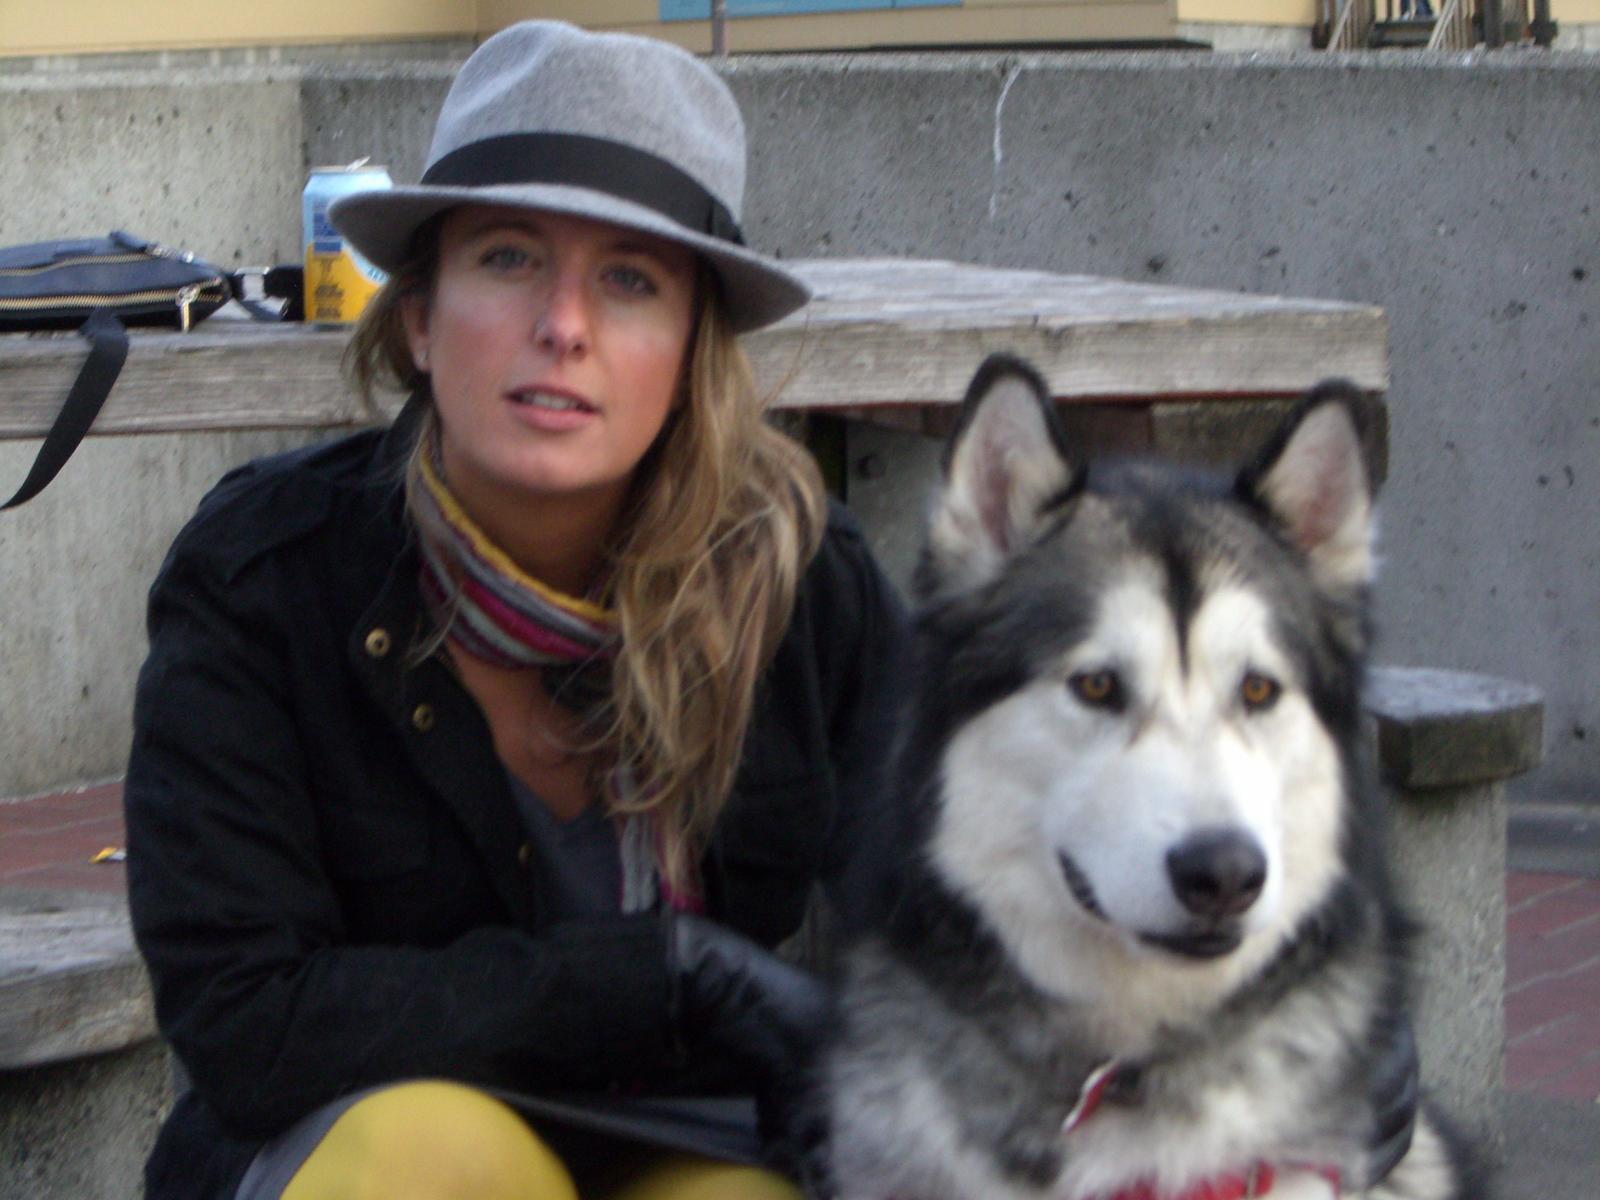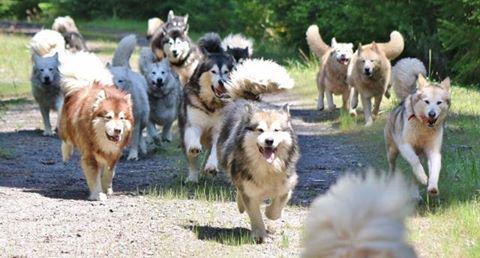The first image is the image on the left, the second image is the image on the right. For the images shown, is this caption "A dark-haired girl has her arms around at least one dog in one image, and the other image shows just one dog that is not interacting." true? Answer yes or no. No. The first image is the image on the left, the second image is the image on the right. Evaluate the accuracy of this statement regarding the images: "The left image contains no more than one dog.". Is it true? Answer yes or no. Yes. 